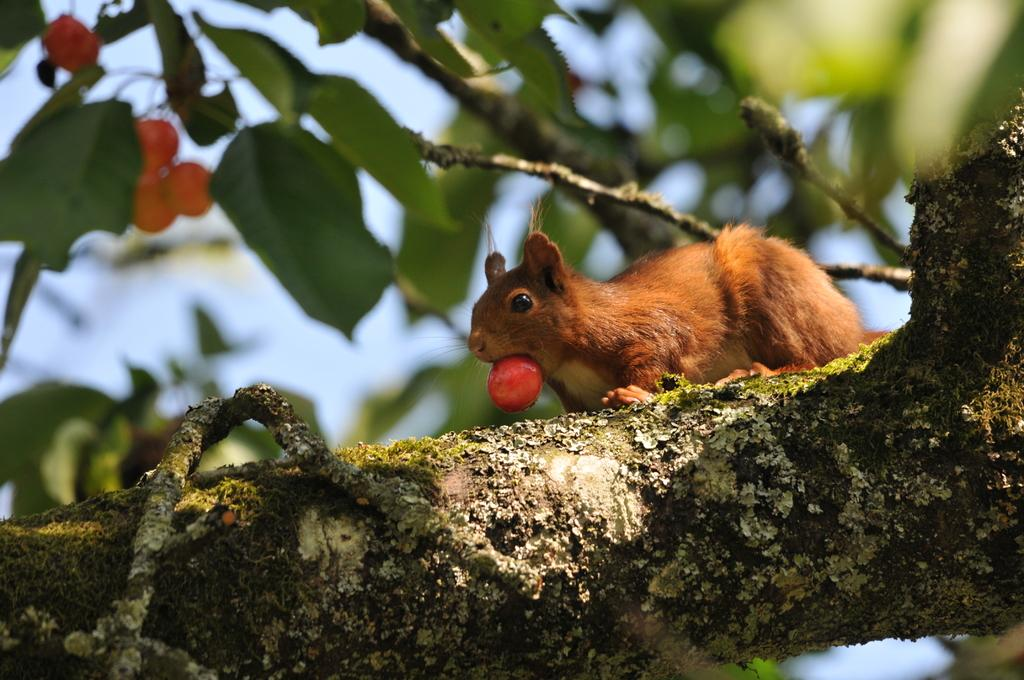What animal is present in the image? There is a squirrel in the image. Where is the squirrel located? The squirrel is on a stem. What is the squirrel doing in the image? The squirrel is eating fruit. What can be seen behind the squirrel? There is a tree behind the squirrel. What is visible behind the tree? The sky is visible behind the tree. What type of trousers is the squirrel wearing while eating cherries in the image? There is no indication that the squirrel is wearing trousers or eating cherries in the image. 